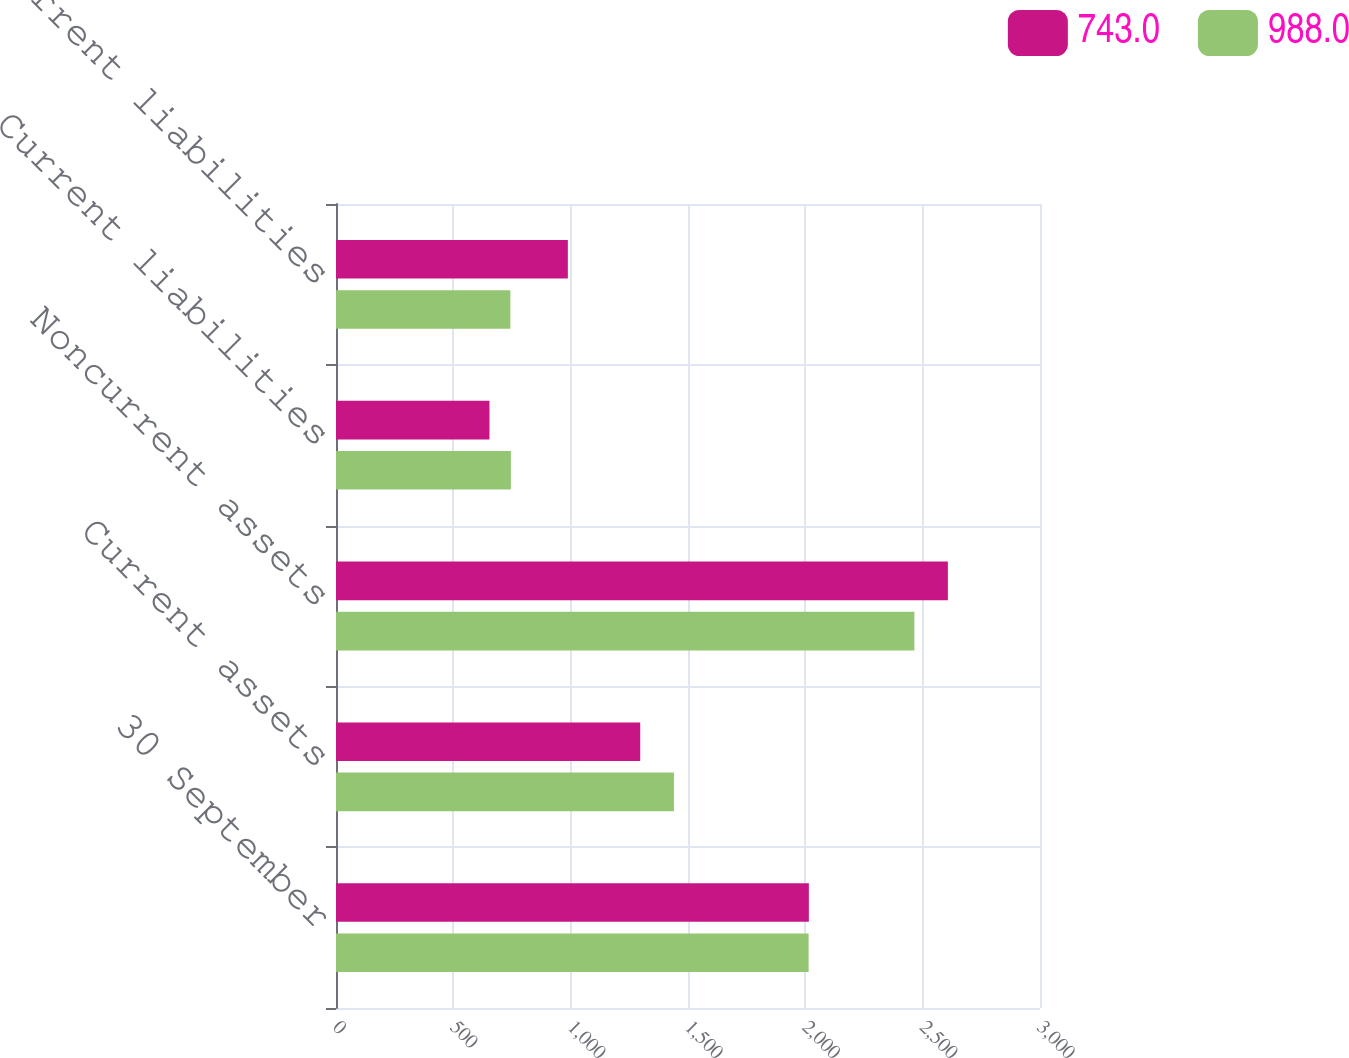Convert chart to OTSL. <chart><loc_0><loc_0><loc_500><loc_500><stacked_bar_chart><ecel><fcel>30 September<fcel>Current assets<fcel>Noncurrent assets<fcel>Current liabilities<fcel>Noncurrent liabilities<nl><fcel>743<fcel>2015<fcel>1296.4<fcel>2607.4<fcel>654<fcel>988<nl><fcel>988<fcel>2014<fcel>1440<fcel>2464.6<fcel>745.2<fcel>743<nl></chart> 